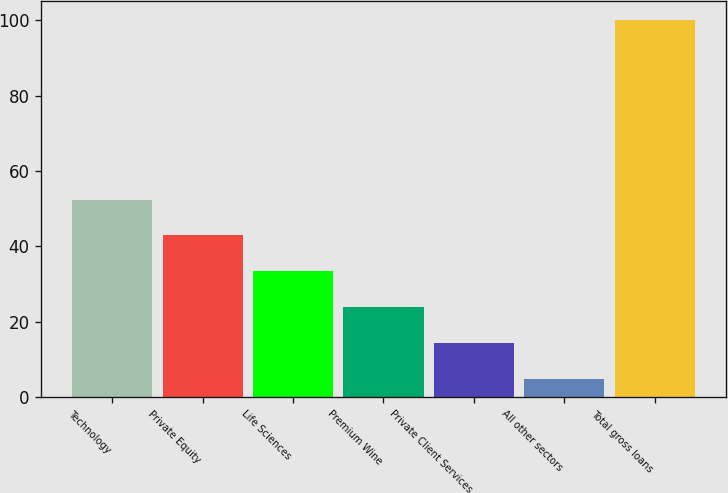Convert chart. <chart><loc_0><loc_0><loc_500><loc_500><bar_chart><fcel>Technology<fcel>Private Equity<fcel>Life Sciences<fcel>Premium Wine<fcel>Private Client Services<fcel>All other sectors<fcel>Total gross loans<nl><fcel>52.4<fcel>42.88<fcel>33.36<fcel>23.84<fcel>14.32<fcel>4.8<fcel>100<nl></chart> 